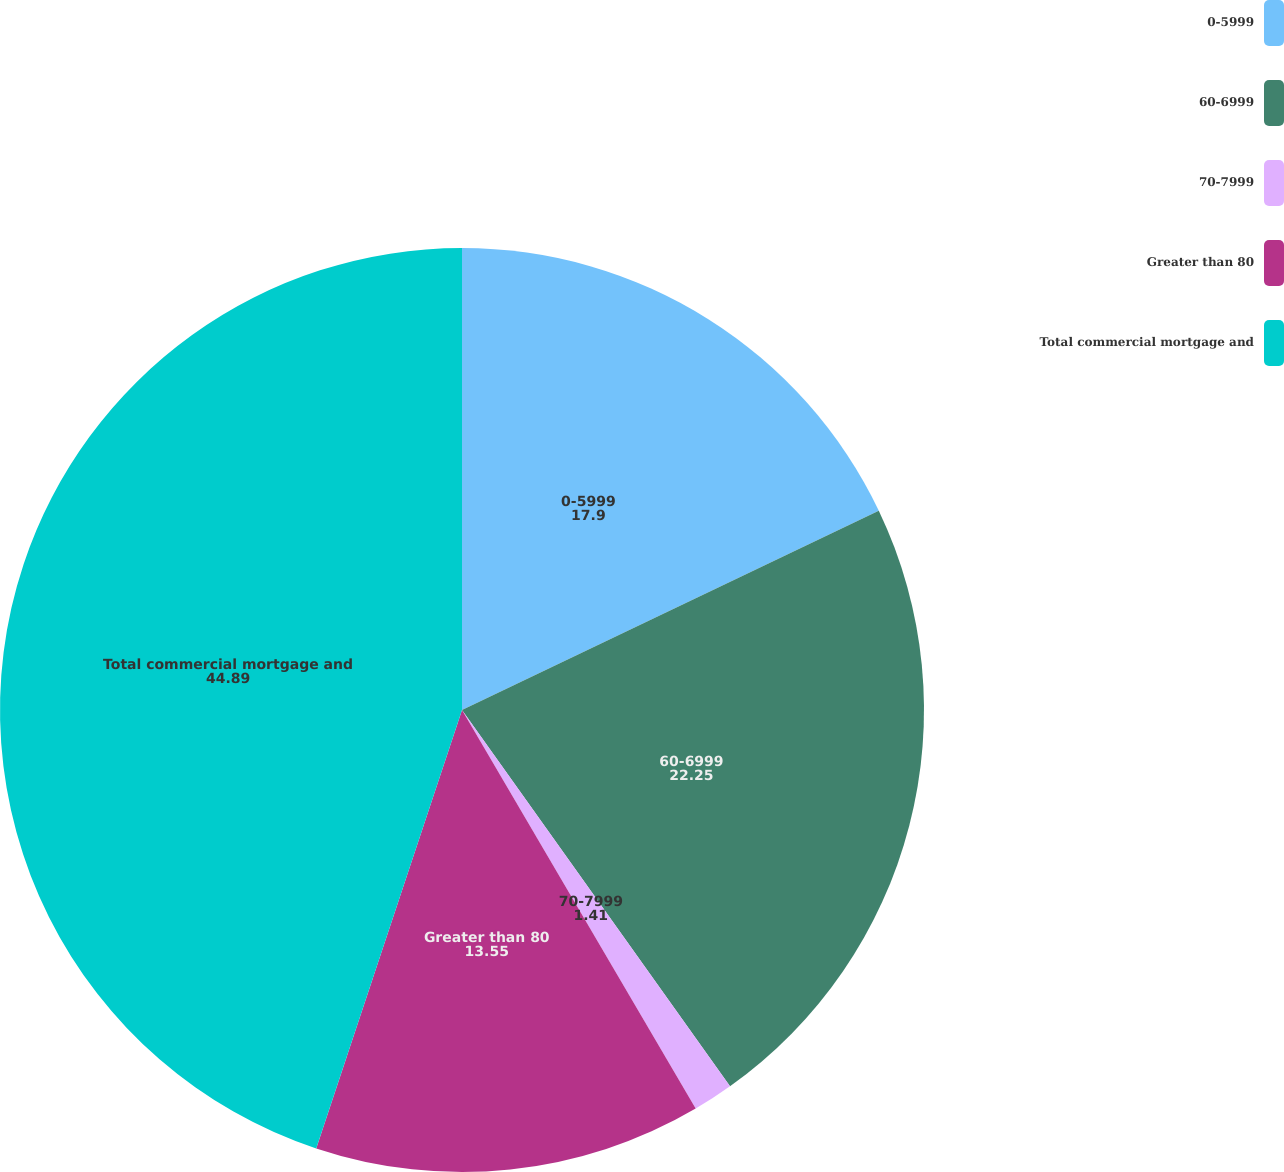<chart> <loc_0><loc_0><loc_500><loc_500><pie_chart><fcel>0-5999<fcel>60-6999<fcel>70-7999<fcel>Greater than 80<fcel>Total commercial mortgage and<nl><fcel>17.9%<fcel>22.25%<fcel>1.41%<fcel>13.55%<fcel>44.89%<nl></chart> 